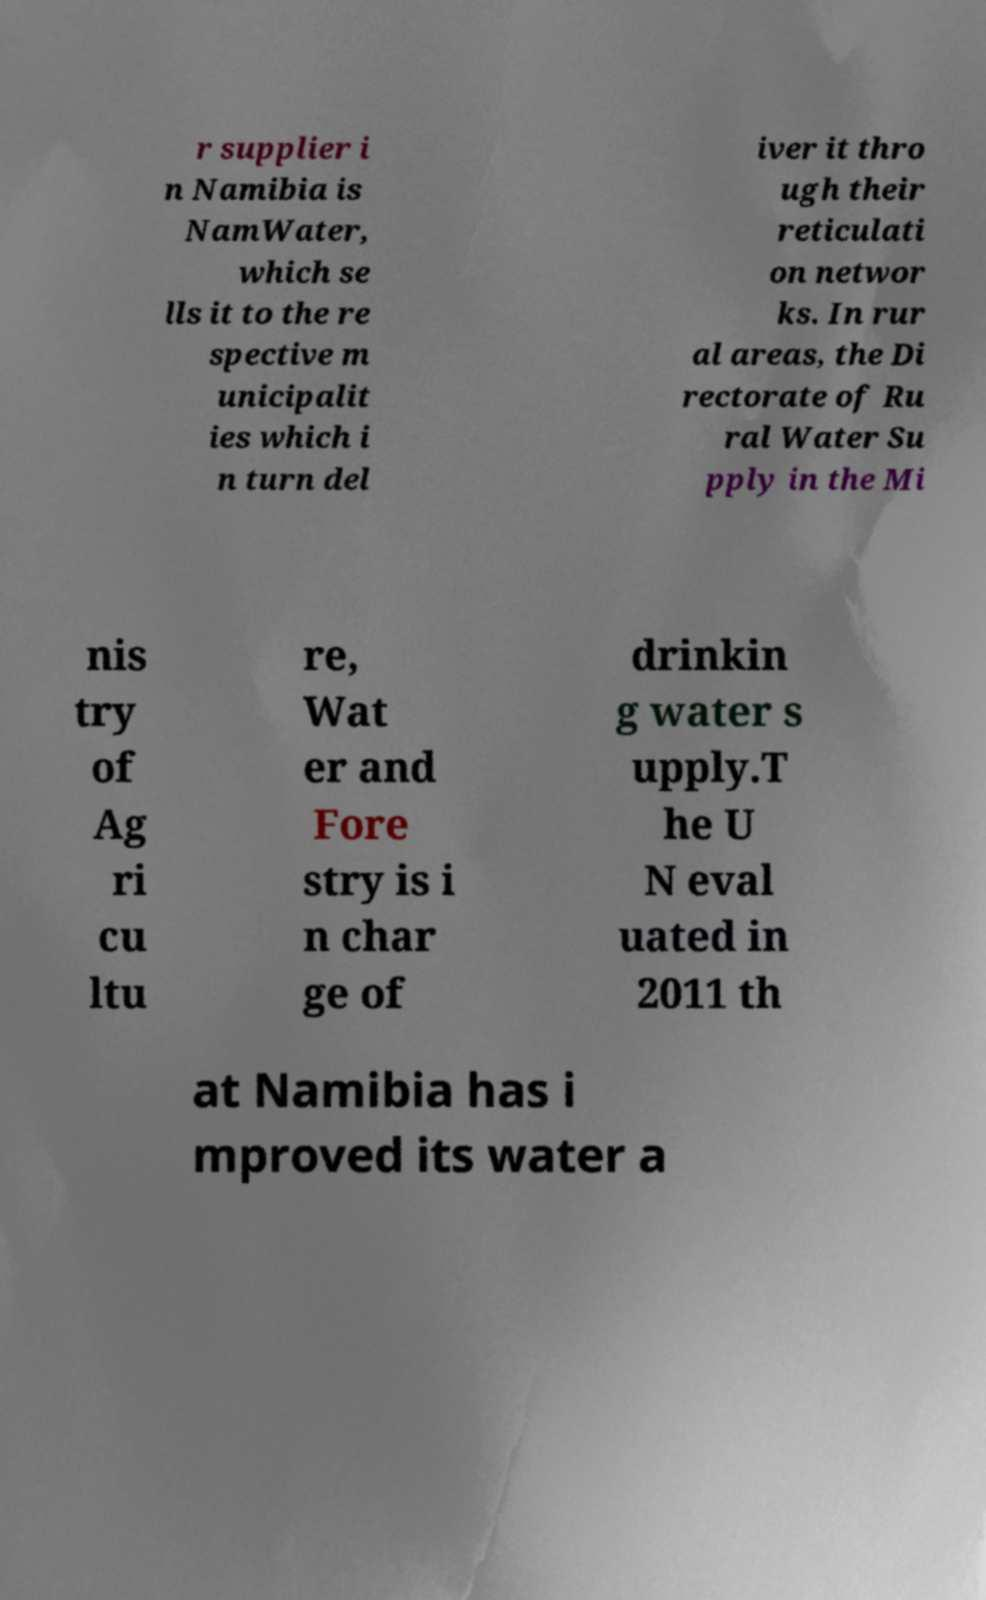There's text embedded in this image that I need extracted. Can you transcribe it verbatim? r supplier i n Namibia is NamWater, which se lls it to the re spective m unicipalit ies which i n turn del iver it thro ugh their reticulati on networ ks. In rur al areas, the Di rectorate of Ru ral Water Su pply in the Mi nis try of Ag ri cu ltu re, Wat er and Fore stry is i n char ge of drinkin g water s upply.T he U N eval uated in 2011 th at Namibia has i mproved its water a 